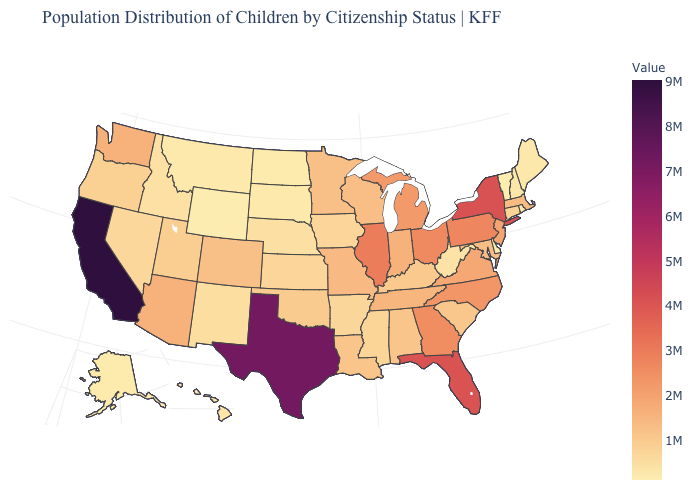Among the states that border West Virginia , which have the highest value?
Write a very short answer. Pennsylvania. Does Minnesota have the highest value in the MidWest?
Give a very brief answer. No. Which states have the lowest value in the MidWest?
Give a very brief answer. North Dakota. Does Indiana have the highest value in the MidWest?
Keep it brief. No. 